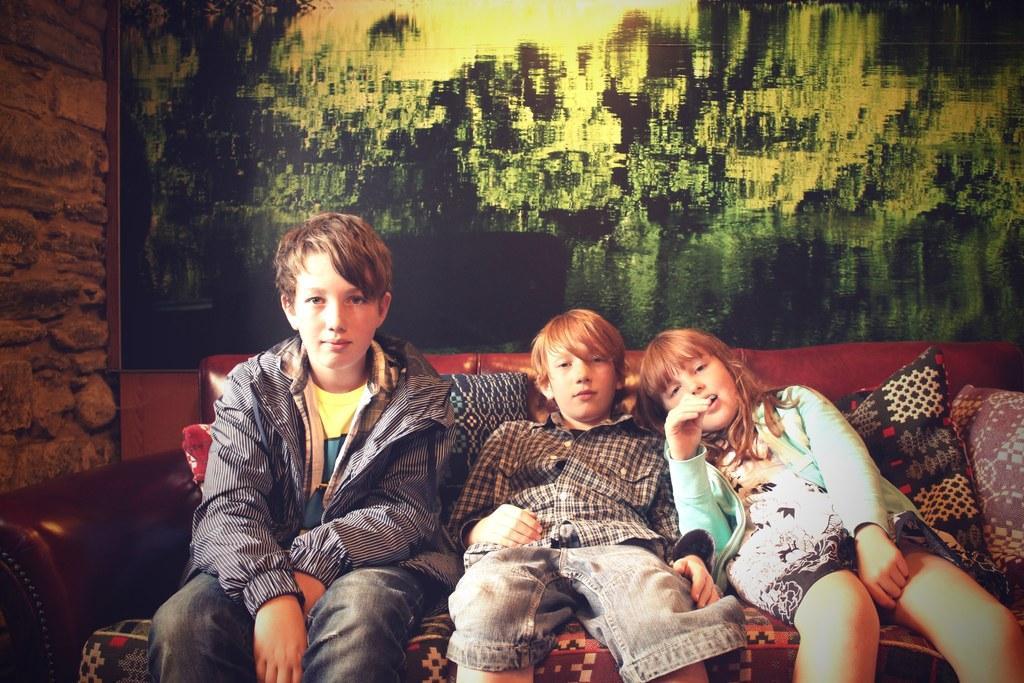Can you describe this image briefly? There are three kids sitting on a sofa and there is a picture behind them. 